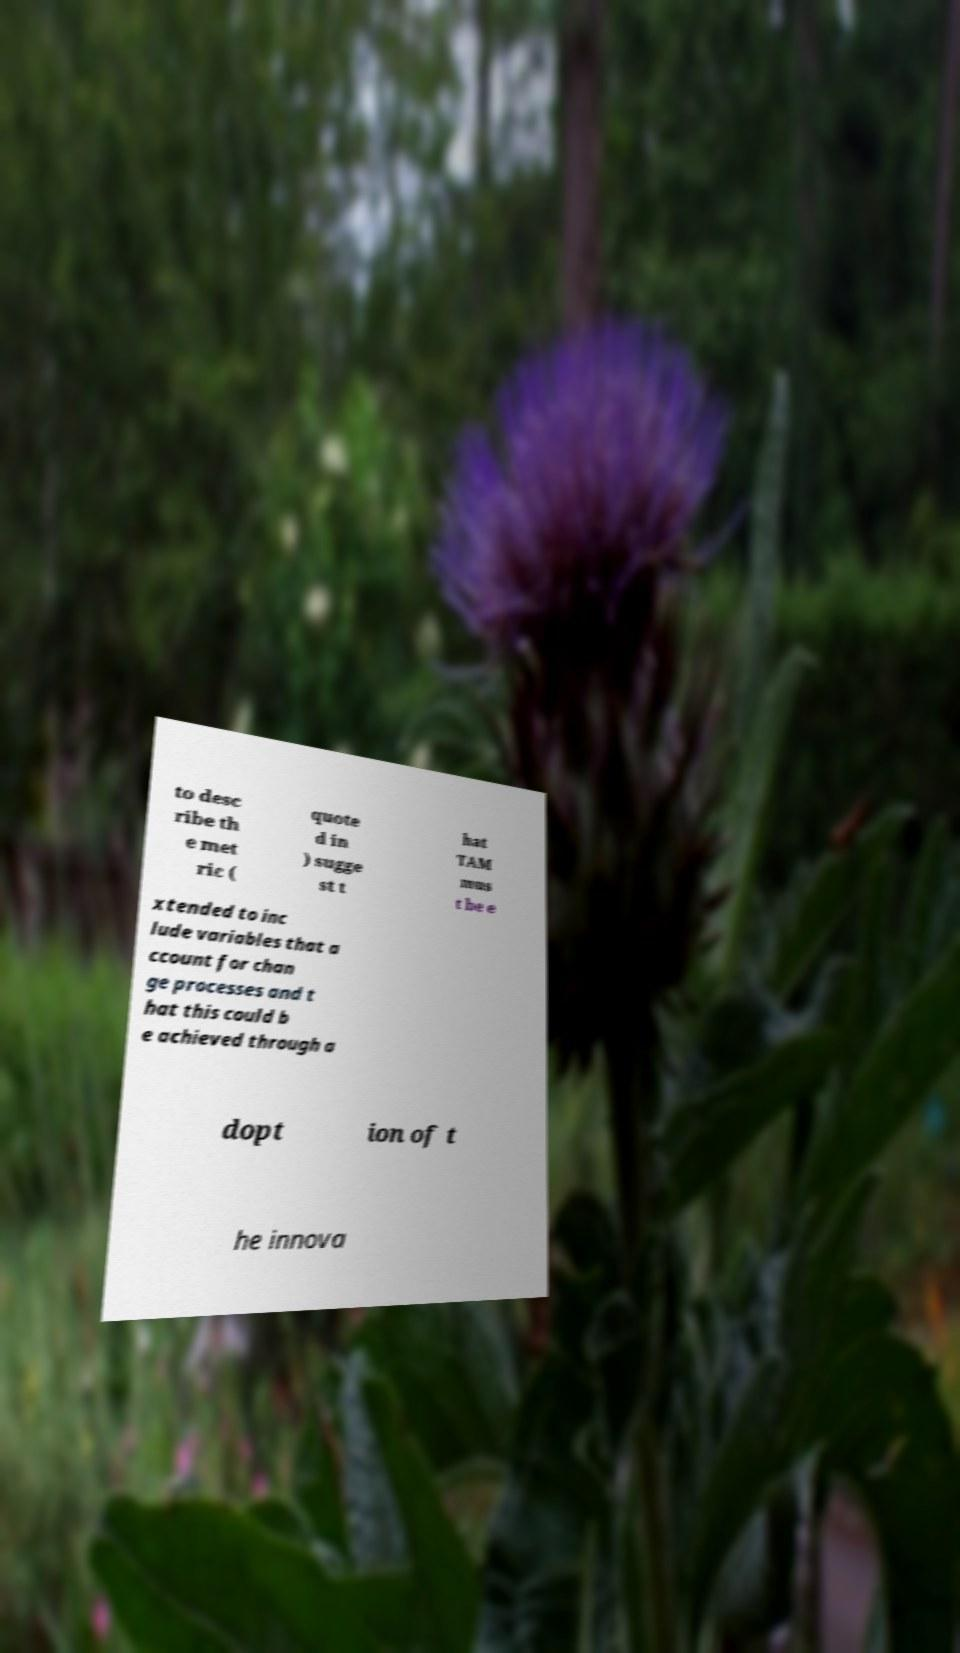What messages or text are displayed in this image? I need them in a readable, typed format. to desc ribe th e met ric ( quote d in ) sugge st t hat TAM mus t be e xtended to inc lude variables that a ccount for chan ge processes and t hat this could b e achieved through a dopt ion of t he innova 